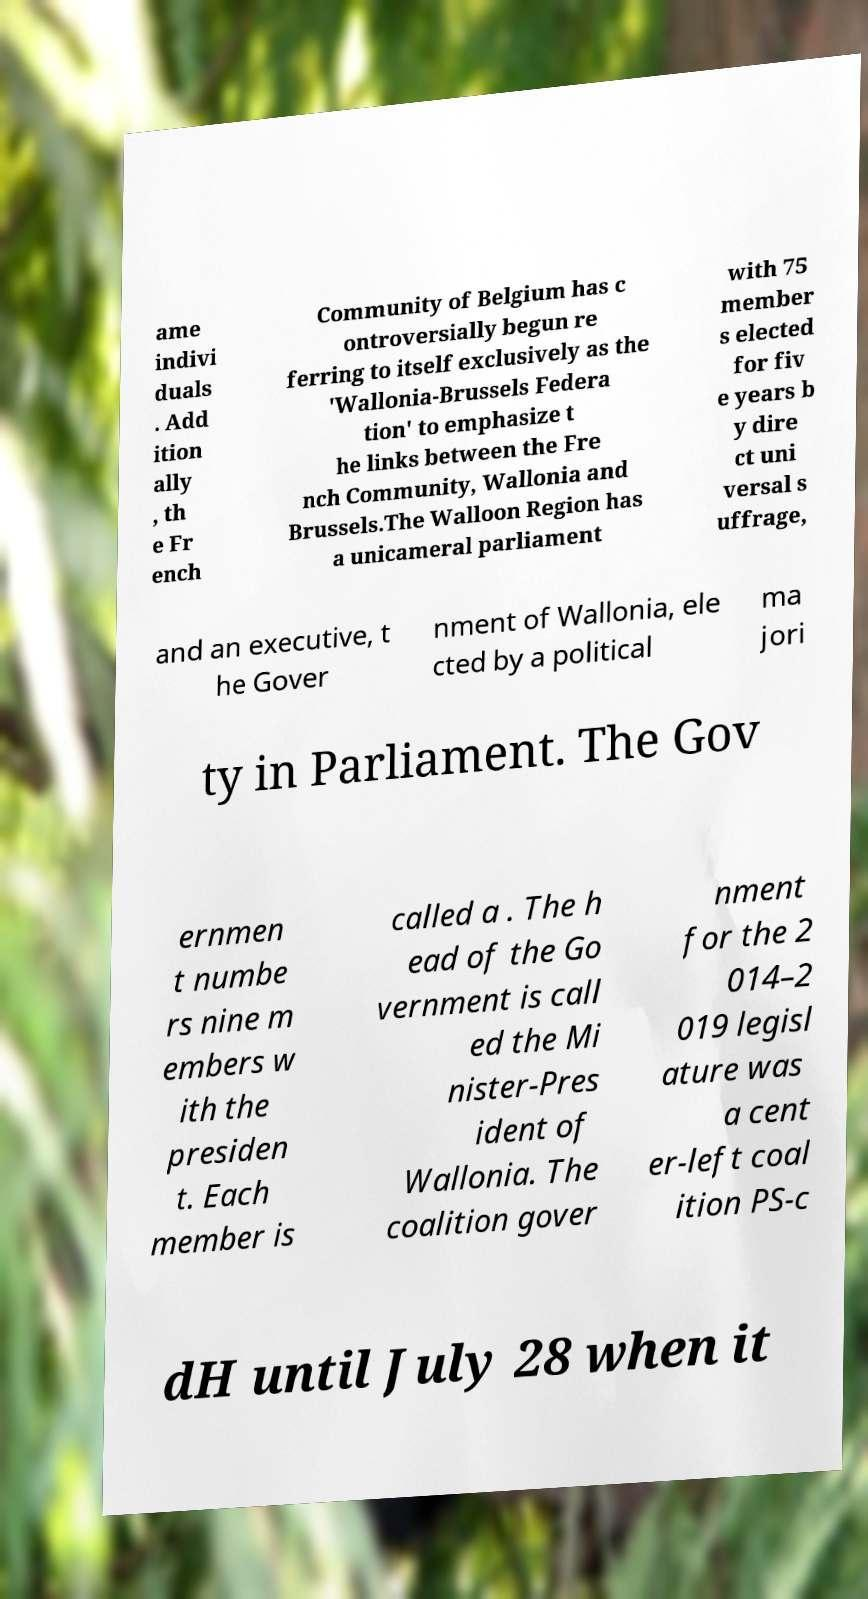Please read and relay the text visible in this image. What does it say? ame indivi duals . Add ition ally , th e Fr ench Community of Belgium has c ontroversially begun re ferring to itself exclusively as the 'Wallonia-Brussels Federa tion' to emphasize t he links between the Fre nch Community, Wallonia and Brussels.The Walloon Region has a unicameral parliament with 75 member s elected for fiv e years b y dire ct uni versal s uffrage, and an executive, t he Gover nment of Wallonia, ele cted by a political ma jori ty in Parliament. The Gov ernmen t numbe rs nine m embers w ith the presiden t. Each member is called a . The h ead of the Go vernment is call ed the Mi nister-Pres ident of Wallonia. The coalition gover nment for the 2 014–2 019 legisl ature was a cent er-left coal ition PS-c dH until July 28 when it 